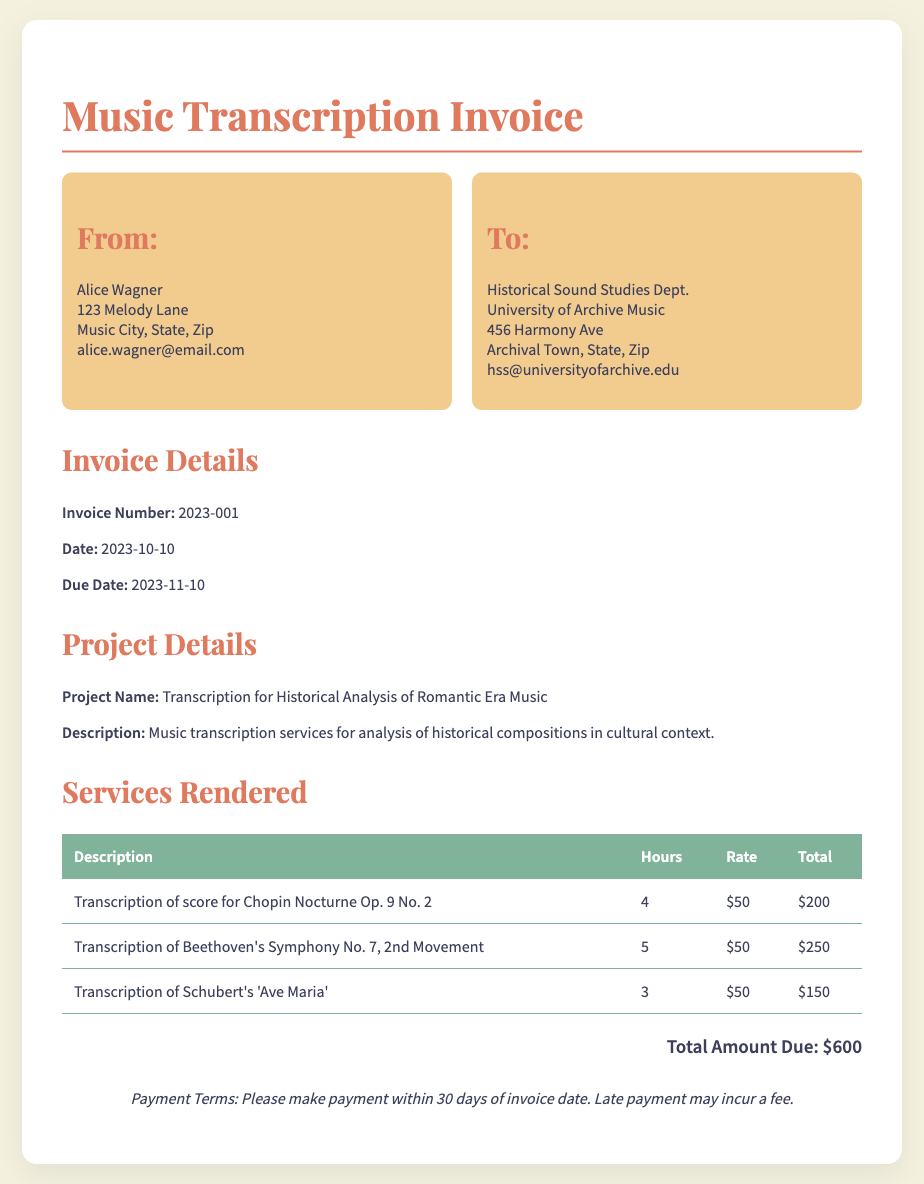what is the invoice number? The invoice number is stated in the document as a unique identifier for the transaction, which is 2023-001.
Answer: 2023-001 what is the total amount due? The total amount due is calculated from the sum of services rendered, which totals to $600.
Answer: $600 who is the provider of the services? The document indicates the service provider as Alice Wagner, as detailed in the "From" section.
Answer: Alice Wagner what is the due date for payment? The due date is mentioned clearly in the document as 2023-11-10.
Answer: 2023-11-10 how many hours were worked on Beethoven's Symphony No. 7 transcription? The hours worked are specified next to the service description in the table, which states 5 hours for this transcription.
Answer: 5 what is the rate per hour for the transcription services? The rate is consistently listed as $50 per hour for all services rendered in the document.
Answer: $50 what is the project name provided in the invoice? The document provides the project name clearly, which is Transcription for Historical Analysis of Romantic Era Music.
Answer: Transcription for Historical Analysis of Romantic Era Music what is the description of the project? The description explains the purpose of the services, specifically detailing it as music transcription services for analysis of historical compositions in cultural context.
Answer: Music transcription services for analysis of historical compositions in cultural context how many different pieces of music were transcribed? The table lists three unique pieces of music that were transcribed, indicating each one separately.
Answer: Three 